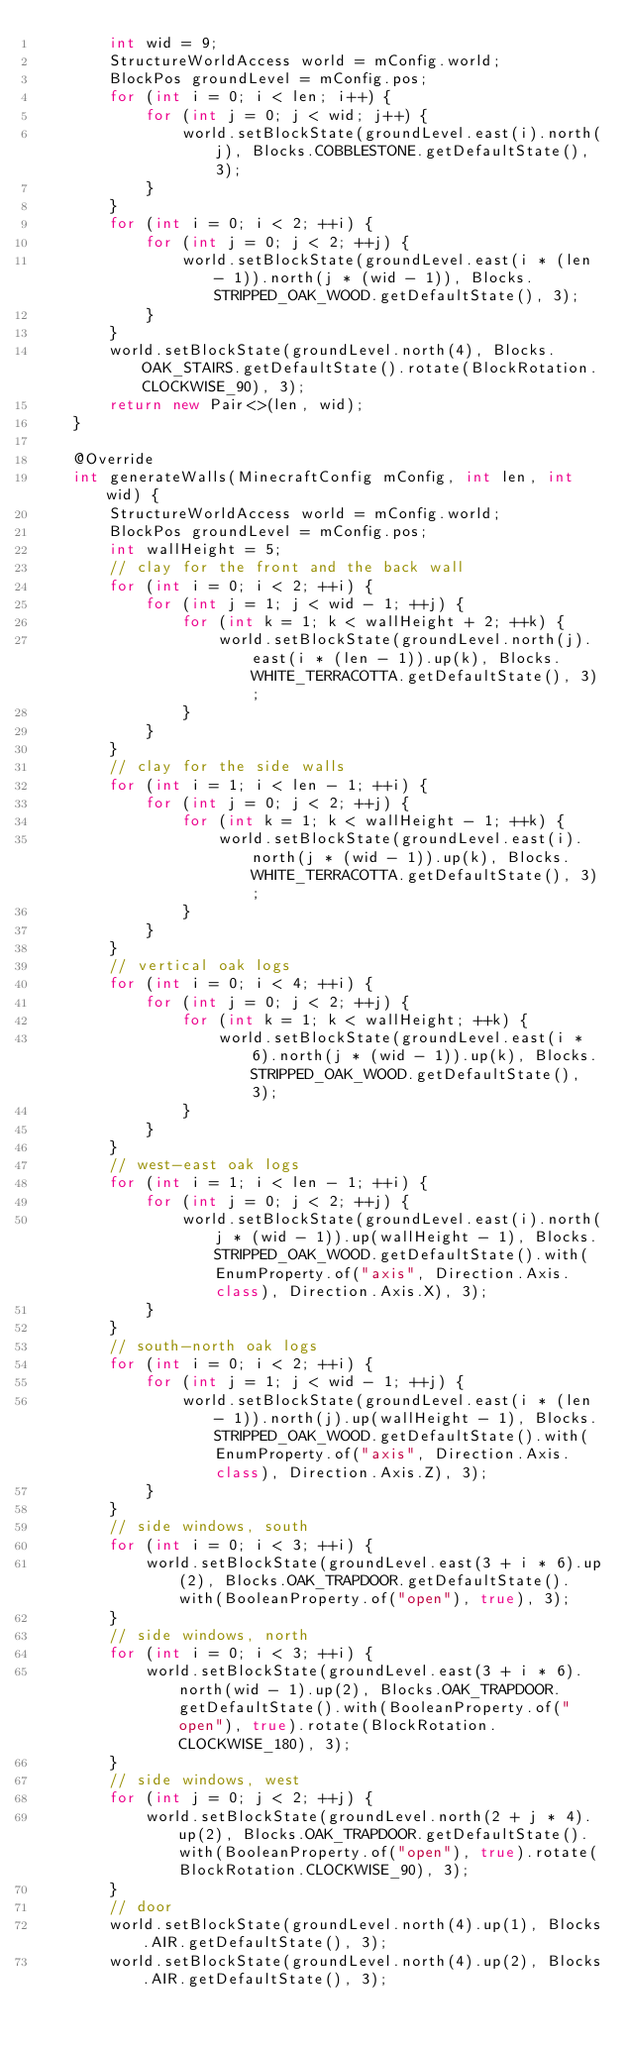Convert code to text. <code><loc_0><loc_0><loc_500><loc_500><_Java_>        int wid = 9;
        StructureWorldAccess world = mConfig.world;
        BlockPos groundLevel = mConfig.pos;
        for (int i = 0; i < len; i++) {
            for (int j = 0; j < wid; j++) {
                world.setBlockState(groundLevel.east(i).north(j), Blocks.COBBLESTONE.getDefaultState(), 3);
            }
        }
        for (int i = 0; i < 2; ++i) {
            for (int j = 0; j < 2; ++j) {
                world.setBlockState(groundLevel.east(i * (len - 1)).north(j * (wid - 1)), Blocks.STRIPPED_OAK_WOOD.getDefaultState(), 3);
            }
        }
        world.setBlockState(groundLevel.north(4), Blocks.OAK_STAIRS.getDefaultState().rotate(BlockRotation.CLOCKWISE_90), 3);
        return new Pair<>(len, wid);
    }

    @Override
    int generateWalls(MinecraftConfig mConfig, int len, int wid) {
        StructureWorldAccess world = mConfig.world;
        BlockPos groundLevel = mConfig.pos;
        int wallHeight = 5;
        // clay for the front and the back wall
        for (int i = 0; i < 2; ++i) {
            for (int j = 1; j < wid - 1; ++j) {
                for (int k = 1; k < wallHeight + 2; ++k) {
                    world.setBlockState(groundLevel.north(j).east(i * (len - 1)).up(k), Blocks.WHITE_TERRACOTTA.getDefaultState(), 3);
                }
            }
        }
        // clay for the side walls
        for (int i = 1; i < len - 1; ++i) {
            for (int j = 0; j < 2; ++j) {
                for (int k = 1; k < wallHeight - 1; ++k) {
                    world.setBlockState(groundLevel.east(i).north(j * (wid - 1)).up(k), Blocks.WHITE_TERRACOTTA.getDefaultState(), 3);
                }
            }
        }
        // vertical oak logs
        for (int i = 0; i < 4; ++i) {
            for (int j = 0; j < 2; ++j) {
                for (int k = 1; k < wallHeight; ++k) {
                    world.setBlockState(groundLevel.east(i * 6).north(j * (wid - 1)).up(k), Blocks.STRIPPED_OAK_WOOD.getDefaultState(), 3);
                }
            }
        }
        // west-east oak logs
        for (int i = 1; i < len - 1; ++i) {
            for (int j = 0; j < 2; ++j) {
                world.setBlockState(groundLevel.east(i).north(j * (wid - 1)).up(wallHeight - 1), Blocks.STRIPPED_OAK_WOOD.getDefaultState().with(EnumProperty.of("axis", Direction.Axis.class), Direction.Axis.X), 3);
            }
        }
        // south-north oak logs
        for (int i = 0; i < 2; ++i) {
            for (int j = 1; j < wid - 1; ++j) {
                world.setBlockState(groundLevel.east(i * (len - 1)).north(j).up(wallHeight - 1), Blocks.STRIPPED_OAK_WOOD.getDefaultState().with(EnumProperty.of("axis", Direction.Axis.class), Direction.Axis.Z), 3);
            }
        }
        // side windows, south
        for (int i = 0; i < 3; ++i) {
            world.setBlockState(groundLevel.east(3 + i * 6).up(2), Blocks.OAK_TRAPDOOR.getDefaultState().with(BooleanProperty.of("open"), true), 3);
        }
        // side windows, north
        for (int i = 0; i < 3; ++i) {
            world.setBlockState(groundLevel.east(3 + i * 6).north(wid - 1).up(2), Blocks.OAK_TRAPDOOR.getDefaultState().with(BooleanProperty.of("open"), true).rotate(BlockRotation.CLOCKWISE_180), 3);
        }
        // side windows, west
        for (int j = 0; j < 2; ++j) {
            world.setBlockState(groundLevel.north(2 + j * 4).up(2), Blocks.OAK_TRAPDOOR.getDefaultState().with(BooleanProperty.of("open"), true).rotate(BlockRotation.CLOCKWISE_90), 3);
        }
        // door
        world.setBlockState(groundLevel.north(4).up(1), Blocks.AIR.getDefaultState(), 3);
        world.setBlockState(groundLevel.north(4).up(2), Blocks.AIR.getDefaultState(), 3);</code> 